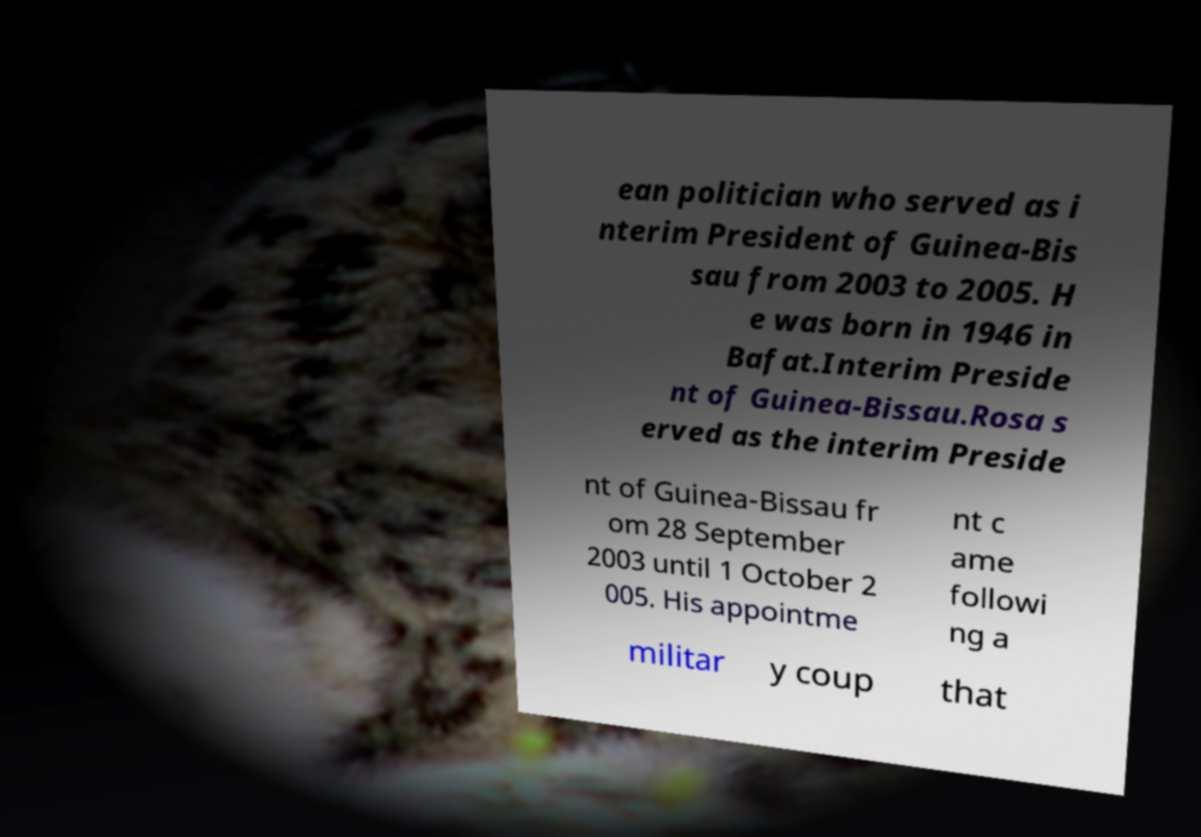Can you read and provide the text displayed in the image?This photo seems to have some interesting text. Can you extract and type it out for me? ean politician who served as i nterim President of Guinea-Bis sau from 2003 to 2005. H e was born in 1946 in Bafat.Interim Preside nt of Guinea-Bissau.Rosa s erved as the interim Preside nt of Guinea-Bissau fr om 28 September 2003 until 1 October 2 005. His appointme nt c ame followi ng a militar y coup that 